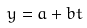Convert formula to latex. <formula><loc_0><loc_0><loc_500><loc_500>y = a + b t</formula> 